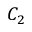Convert formula to latex. <formula><loc_0><loc_0><loc_500><loc_500>C _ { 2 }</formula> 